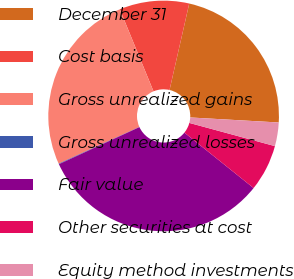Convert chart to OTSL. <chart><loc_0><loc_0><loc_500><loc_500><pie_chart><fcel>December 31<fcel>Cost basis<fcel>Gross unrealized gains<fcel>Gross unrealized losses<fcel>Fair value<fcel>Other securities at cost<fcel>Equity method investments<nl><fcel>22.34%<fcel>9.77%<fcel>25.59%<fcel>0.08%<fcel>32.38%<fcel>6.54%<fcel>3.31%<nl></chart> 